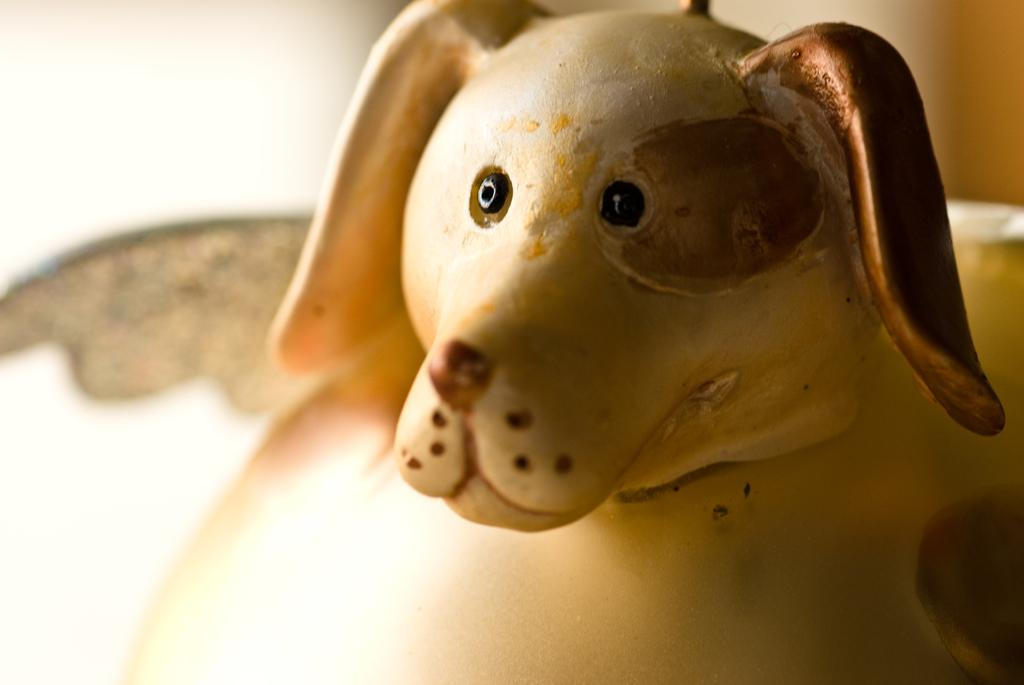What type of living creature is present in the image? There is an animal in the image. Can you describe the background of the image? The background of the image is blurred. What type of vase is being used by the toad to run in the image? There is no vase or toad present in the image, and therefore no such activity can be observed. 